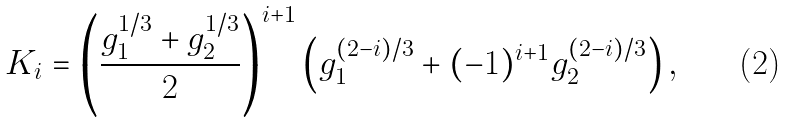Convert formula to latex. <formula><loc_0><loc_0><loc_500><loc_500>K _ { i } = \left ( \frac { g _ { 1 } ^ { 1 / 3 } + g _ { 2 } ^ { 1 / 3 } } { 2 } \right ) ^ { i + 1 } \left ( g _ { 1 } ^ { ( 2 - i ) / 3 } + ( - 1 ) ^ { i + 1 } g _ { 2 } ^ { ( 2 - i ) / 3 } \right ) ,</formula> 